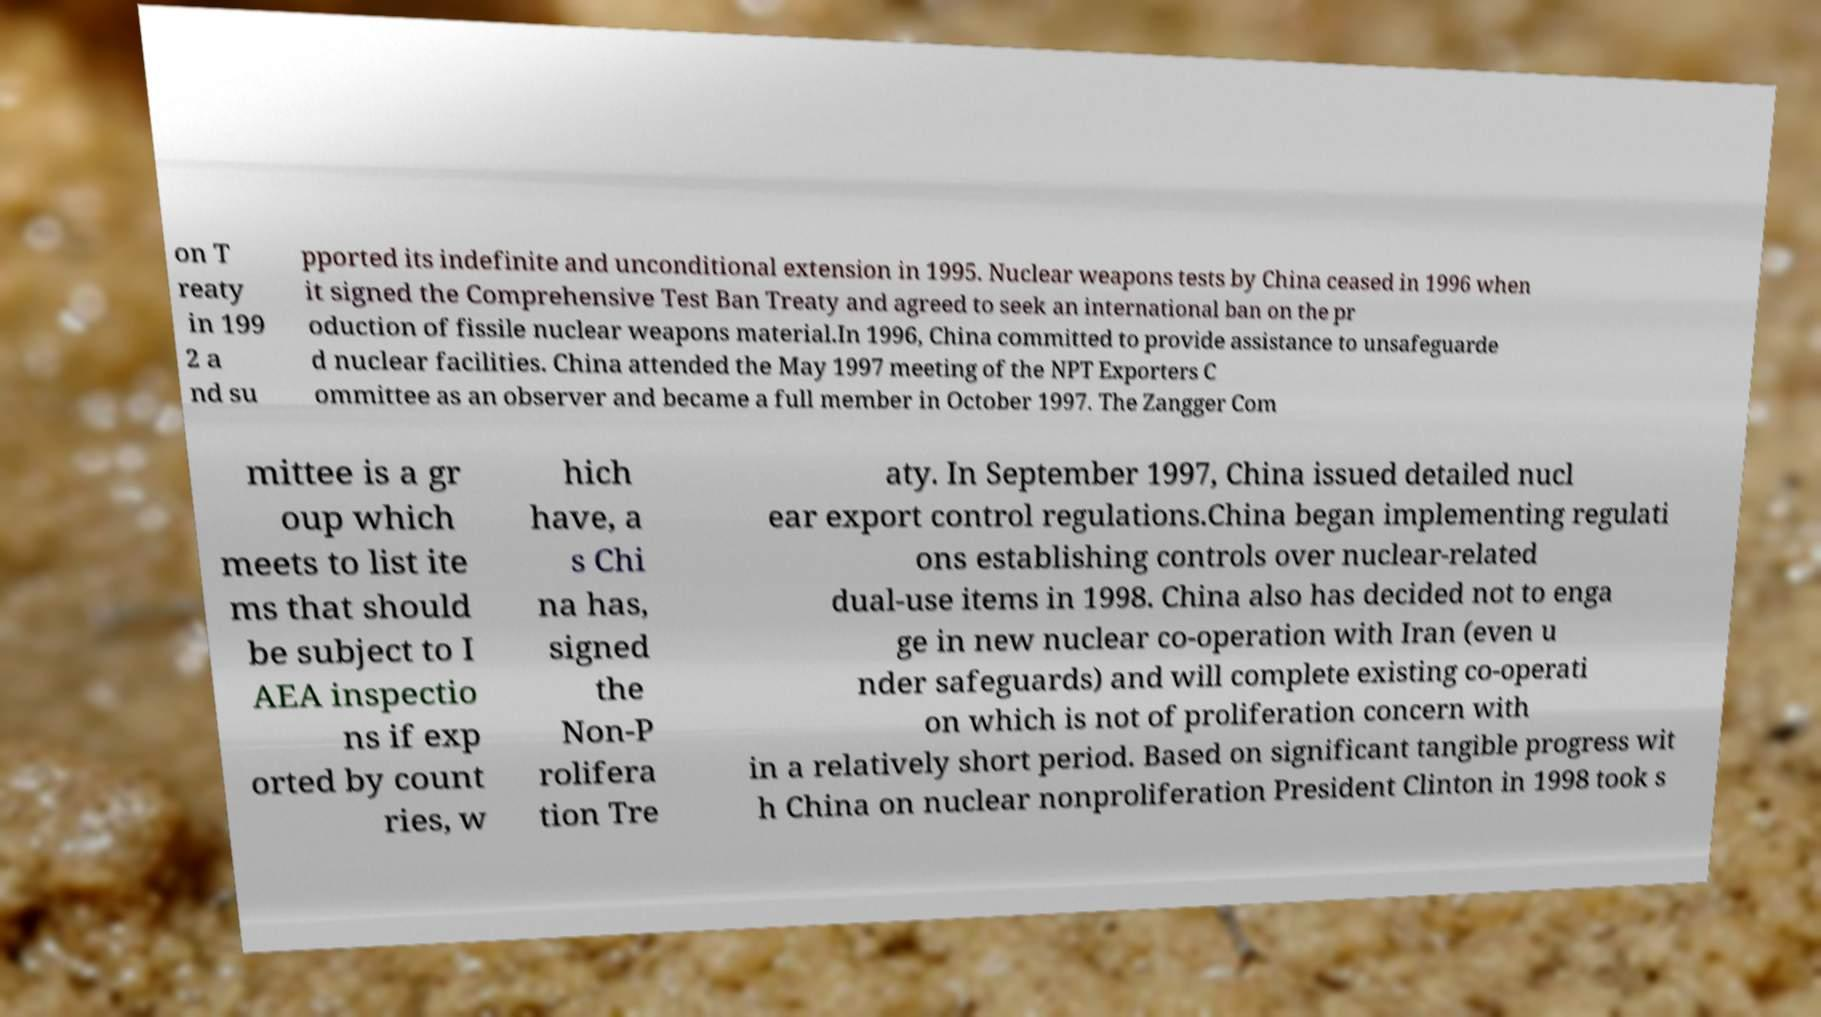Could you assist in decoding the text presented in this image and type it out clearly? on T reaty in 199 2 a nd su pported its indefinite and unconditional extension in 1995. Nuclear weapons tests by China ceased in 1996 when it signed the Comprehensive Test Ban Treaty and agreed to seek an international ban on the pr oduction of fissile nuclear weapons material.In 1996, China committed to provide assistance to unsafeguarde d nuclear facilities. China attended the May 1997 meeting of the NPT Exporters C ommittee as an observer and became a full member in October 1997. The Zangger Com mittee is a gr oup which meets to list ite ms that should be subject to I AEA inspectio ns if exp orted by count ries, w hich have, a s Chi na has, signed the Non-P rolifera tion Tre aty. In September 1997, China issued detailed nucl ear export control regulations.China began implementing regulati ons establishing controls over nuclear-related dual-use items in 1998. China also has decided not to enga ge in new nuclear co-operation with Iran (even u nder safeguards) and will complete existing co-operati on which is not of proliferation concern with in a relatively short period. Based on significant tangible progress wit h China on nuclear nonproliferation President Clinton in 1998 took s 